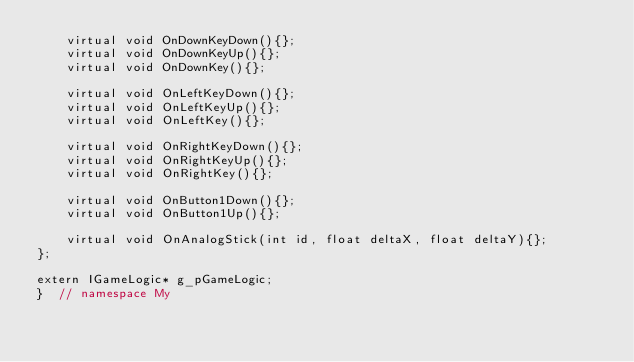Convert code to text. <code><loc_0><loc_0><loc_500><loc_500><_C++_>    virtual void OnDownKeyDown(){};
    virtual void OnDownKeyUp(){};
    virtual void OnDownKey(){};

    virtual void OnLeftKeyDown(){};
    virtual void OnLeftKeyUp(){};
    virtual void OnLeftKey(){};

    virtual void OnRightKeyDown(){};
    virtual void OnRightKeyUp(){};
    virtual void OnRightKey(){};

    virtual void OnButton1Down(){};
    virtual void OnButton1Up(){};

    virtual void OnAnalogStick(int id, float deltaX, float deltaY){};
};

extern IGameLogic* g_pGameLogic;
}  // namespace My</code> 